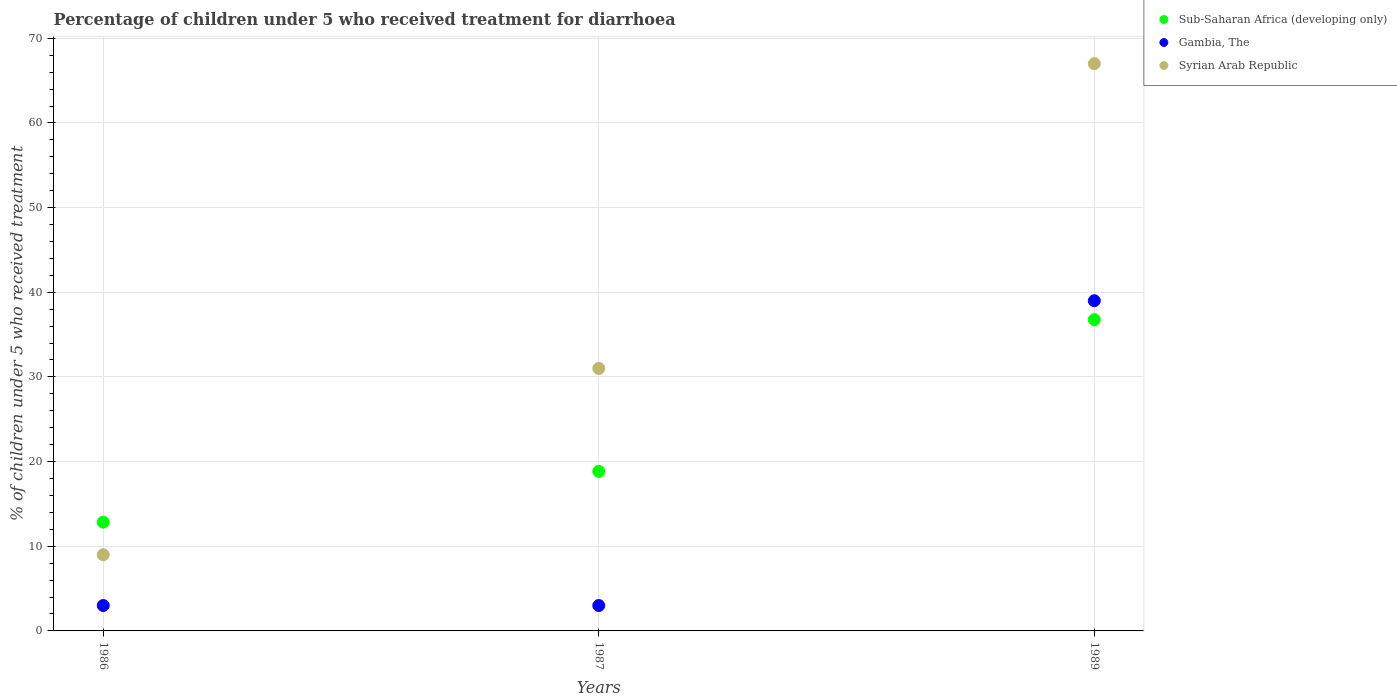How many different coloured dotlines are there?
Offer a very short reply. 3. What is the percentage of children who received treatment for diarrhoea  in Gambia, The in 1986?
Ensure brevity in your answer.  3. Across all years, what is the maximum percentage of children who received treatment for diarrhoea  in Syrian Arab Republic?
Your answer should be compact. 67. In which year was the percentage of children who received treatment for diarrhoea  in Sub-Saharan Africa (developing only) minimum?
Ensure brevity in your answer.  1986. What is the total percentage of children who received treatment for diarrhoea  in Sub-Saharan Africa (developing only) in the graph?
Provide a succinct answer. 68.46. What is the difference between the percentage of children who received treatment for diarrhoea  in Gambia, The in 1987 and that in 1989?
Offer a terse response. -36. What is the difference between the percentage of children who received treatment for diarrhoea  in Sub-Saharan Africa (developing only) in 1986 and the percentage of children who received treatment for diarrhoea  in Gambia, The in 1987?
Offer a terse response. 9.84. What is the average percentage of children who received treatment for diarrhoea  in Sub-Saharan Africa (developing only) per year?
Provide a succinct answer. 22.82. In how many years, is the percentage of children who received treatment for diarrhoea  in Sub-Saharan Africa (developing only) greater than 36 %?
Offer a very short reply. 1. What is the ratio of the percentage of children who received treatment for diarrhoea  in Gambia, The in 1986 to that in 1989?
Offer a very short reply. 0.08. Is the percentage of children who received treatment for diarrhoea  in Syrian Arab Republic in 1986 less than that in 1989?
Provide a succinct answer. Yes. What is the difference between the highest and the lowest percentage of children who received treatment for diarrhoea  in Sub-Saharan Africa (developing only)?
Your answer should be compact. 23.92. Is the sum of the percentage of children who received treatment for diarrhoea  in Gambia, The in 1987 and 1989 greater than the maximum percentage of children who received treatment for diarrhoea  in Sub-Saharan Africa (developing only) across all years?
Your answer should be very brief. Yes. Is it the case that in every year, the sum of the percentage of children who received treatment for diarrhoea  in Gambia, The and percentage of children who received treatment for diarrhoea  in Sub-Saharan Africa (developing only)  is greater than the percentage of children who received treatment for diarrhoea  in Syrian Arab Republic?
Give a very brief answer. No. Does the percentage of children who received treatment for diarrhoea  in Syrian Arab Republic monotonically increase over the years?
Keep it short and to the point. Yes. Is the percentage of children who received treatment for diarrhoea  in Gambia, The strictly greater than the percentage of children who received treatment for diarrhoea  in Syrian Arab Republic over the years?
Provide a succinct answer. No. How many years are there in the graph?
Your response must be concise. 3. Are the values on the major ticks of Y-axis written in scientific E-notation?
Make the answer very short. No. Does the graph contain any zero values?
Offer a terse response. No. What is the title of the graph?
Your response must be concise. Percentage of children under 5 who received treatment for diarrhoea. Does "Pakistan" appear as one of the legend labels in the graph?
Provide a short and direct response. No. What is the label or title of the Y-axis?
Offer a terse response. % of children under 5 who received treatment. What is the % of children under 5 who received treatment of Sub-Saharan Africa (developing only) in 1986?
Offer a very short reply. 12.84. What is the % of children under 5 who received treatment in Syrian Arab Republic in 1986?
Give a very brief answer. 9. What is the % of children under 5 who received treatment of Sub-Saharan Africa (developing only) in 1987?
Ensure brevity in your answer.  18.84. What is the % of children under 5 who received treatment in Syrian Arab Republic in 1987?
Your response must be concise. 31. What is the % of children under 5 who received treatment of Sub-Saharan Africa (developing only) in 1989?
Keep it short and to the point. 36.77. Across all years, what is the maximum % of children under 5 who received treatment in Sub-Saharan Africa (developing only)?
Your response must be concise. 36.77. Across all years, what is the minimum % of children under 5 who received treatment of Sub-Saharan Africa (developing only)?
Offer a very short reply. 12.84. Across all years, what is the minimum % of children under 5 who received treatment in Gambia, The?
Offer a terse response. 3. Across all years, what is the minimum % of children under 5 who received treatment in Syrian Arab Republic?
Your answer should be very brief. 9. What is the total % of children under 5 who received treatment in Sub-Saharan Africa (developing only) in the graph?
Provide a short and direct response. 68.46. What is the total % of children under 5 who received treatment of Gambia, The in the graph?
Ensure brevity in your answer.  45. What is the total % of children under 5 who received treatment in Syrian Arab Republic in the graph?
Offer a very short reply. 107. What is the difference between the % of children under 5 who received treatment in Sub-Saharan Africa (developing only) in 1986 and that in 1987?
Offer a terse response. -6. What is the difference between the % of children under 5 who received treatment of Gambia, The in 1986 and that in 1987?
Give a very brief answer. 0. What is the difference between the % of children under 5 who received treatment in Sub-Saharan Africa (developing only) in 1986 and that in 1989?
Your answer should be very brief. -23.92. What is the difference between the % of children under 5 who received treatment in Gambia, The in 1986 and that in 1989?
Offer a terse response. -36. What is the difference between the % of children under 5 who received treatment in Syrian Arab Republic in 1986 and that in 1989?
Your response must be concise. -58. What is the difference between the % of children under 5 who received treatment of Sub-Saharan Africa (developing only) in 1987 and that in 1989?
Make the answer very short. -17.92. What is the difference between the % of children under 5 who received treatment in Gambia, The in 1987 and that in 1989?
Keep it short and to the point. -36. What is the difference between the % of children under 5 who received treatment in Syrian Arab Republic in 1987 and that in 1989?
Give a very brief answer. -36. What is the difference between the % of children under 5 who received treatment in Sub-Saharan Africa (developing only) in 1986 and the % of children under 5 who received treatment in Gambia, The in 1987?
Make the answer very short. 9.84. What is the difference between the % of children under 5 who received treatment of Sub-Saharan Africa (developing only) in 1986 and the % of children under 5 who received treatment of Syrian Arab Republic in 1987?
Make the answer very short. -18.16. What is the difference between the % of children under 5 who received treatment of Gambia, The in 1986 and the % of children under 5 who received treatment of Syrian Arab Republic in 1987?
Your response must be concise. -28. What is the difference between the % of children under 5 who received treatment in Sub-Saharan Africa (developing only) in 1986 and the % of children under 5 who received treatment in Gambia, The in 1989?
Give a very brief answer. -26.16. What is the difference between the % of children under 5 who received treatment of Sub-Saharan Africa (developing only) in 1986 and the % of children under 5 who received treatment of Syrian Arab Republic in 1989?
Offer a terse response. -54.16. What is the difference between the % of children under 5 who received treatment of Gambia, The in 1986 and the % of children under 5 who received treatment of Syrian Arab Republic in 1989?
Ensure brevity in your answer.  -64. What is the difference between the % of children under 5 who received treatment of Sub-Saharan Africa (developing only) in 1987 and the % of children under 5 who received treatment of Gambia, The in 1989?
Ensure brevity in your answer.  -20.16. What is the difference between the % of children under 5 who received treatment of Sub-Saharan Africa (developing only) in 1987 and the % of children under 5 who received treatment of Syrian Arab Republic in 1989?
Make the answer very short. -48.16. What is the difference between the % of children under 5 who received treatment of Gambia, The in 1987 and the % of children under 5 who received treatment of Syrian Arab Republic in 1989?
Ensure brevity in your answer.  -64. What is the average % of children under 5 who received treatment in Sub-Saharan Africa (developing only) per year?
Give a very brief answer. 22.82. What is the average % of children under 5 who received treatment in Gambia, The per year?
Ensure brevity in your answer.  15. What is the average % of children under 5 who received treatment in Syrian Arab Republic per year?
Offer a very short reply. 35.67. In the year 1986, what is the difference between the % of children under 5 who received treatment of Sub-Saharan Africa (developing only) and % of children under 5 who received treatment of Gambia, The?
Your answer should be very brief. 9.84. In the year 1986, what is the difference between the % of children under 5 who received treatment of Sub-Saharan Africa (developing only) and % of children under 5 who received treatment of Syrian Arab Republic?
Offer a terse response. 3.84. In the year 1986, what is the difference between the % of children under 5 who received treatment in Gambia, The and % of children under 5 who received treatment in Syrian Arab Republic?
Provide a succinct answer. -6. In the year 1987, what is the difference between the % of children under 5 who received treatment of Sub-Saharan Africa (developing only) and % of children under 5 who received treatment of Gambia, The?
Your answer should be very brief. 15.84. In the year 1987, what is the difference between the % of children under 5 who received treatment in Sub-Saharan Africa (developing only) and % of children under 5 who received treatment in Syrian Arab Republic?
Offer a very short reply. -12.16. In the year 1989, what is the difference between the % of children under 5 who received treatment in Sub-Saharan Africa (developing only) and % of children under 5 who received treatment in Gambia, The?
Give a very brief answer. -2.23. In the year 1989, what is the difference between the % of children under 5 who received treatment of Sub-Saharan Africa (developing only) and % of children under 5 who received treatment of Syrian Arab Republic?
Your response must be concise. -30.23. In the year 1989, what is the difference between the % of children under 5 who received treatment in Gambia, The and % of children under 5 who received treatment in Syrian Arab Republic?
Offer a very short reply. -28. What is the ratio of the % of children under 5 who received treatment in Sub-Saharan Africa (developing only) in 1986 to that in 1987?
Provide a succinct answer. 0.68. What is the ratio of the % of children under 5 who received treatment in Syrian Arab Republic in 1986 to that in 1987?
Offer a terse response. 0.29. What is the ratio of the % of children under 5 who received treatment of Sub-Saharan Africa (developing only) in 1986 to that in 1989?
Offer a very short reply. 0.35. What is the ratio of the % of children under 5 who received treatment of Gambia, The in 1986 to that in 1989?
Ensure brevity in your answer.  0.08. What is the ratio of the % of children under 5 who received treatment of Syrian Arab Republic in 1986 to that in 1989?
Ensure brevity in your answer.  0.13. What is the ratio of the % of children under 5 who received treatment in Sub-Saharan Africa (developing only) in 1987 to that in 1989?
Ensure brevity in your answer.  0.51. What is the ratio of the % of children under 5 who received treatment of Gambia, The in 1987 to that in 1989?
Provide a succinct answer. 0.08. What is the ratio of the % of children under 5 who received treatment in Syrian Arab Republic in 1987 to that in 1989?
Your response must be concise. 0.46. What is the difference between the highest and the second highest % of children under 5 who received treatment of Sub-Saharan Africa (developing only)?
Your response must be concise. 17.92. What is the difference between the highest and the second highest % of children under 5 who received treatment of Syrian Arab Republic?
Keep it short and to the point. 36. What is the difference between the highest and the lowest % of children under 5 who received treatment of Sub-Saharan Africa (developing only)?
Offer a terse response. 23.92. What is the difference between the highest and the lowest % of children under 5 who received treatment of Syrian Arab Republic?
Your answer should be very brief. 58. 